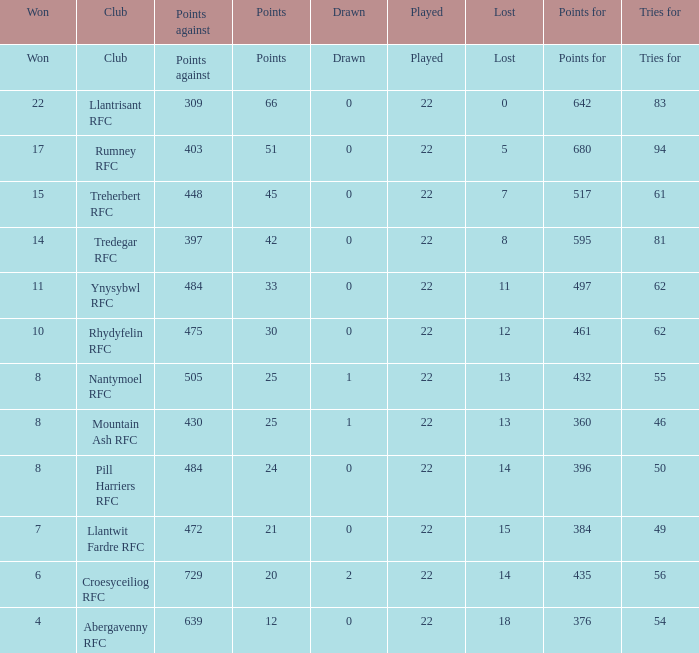How many matches were won by the teams that scored exactly 61 tries for? 15.0. 